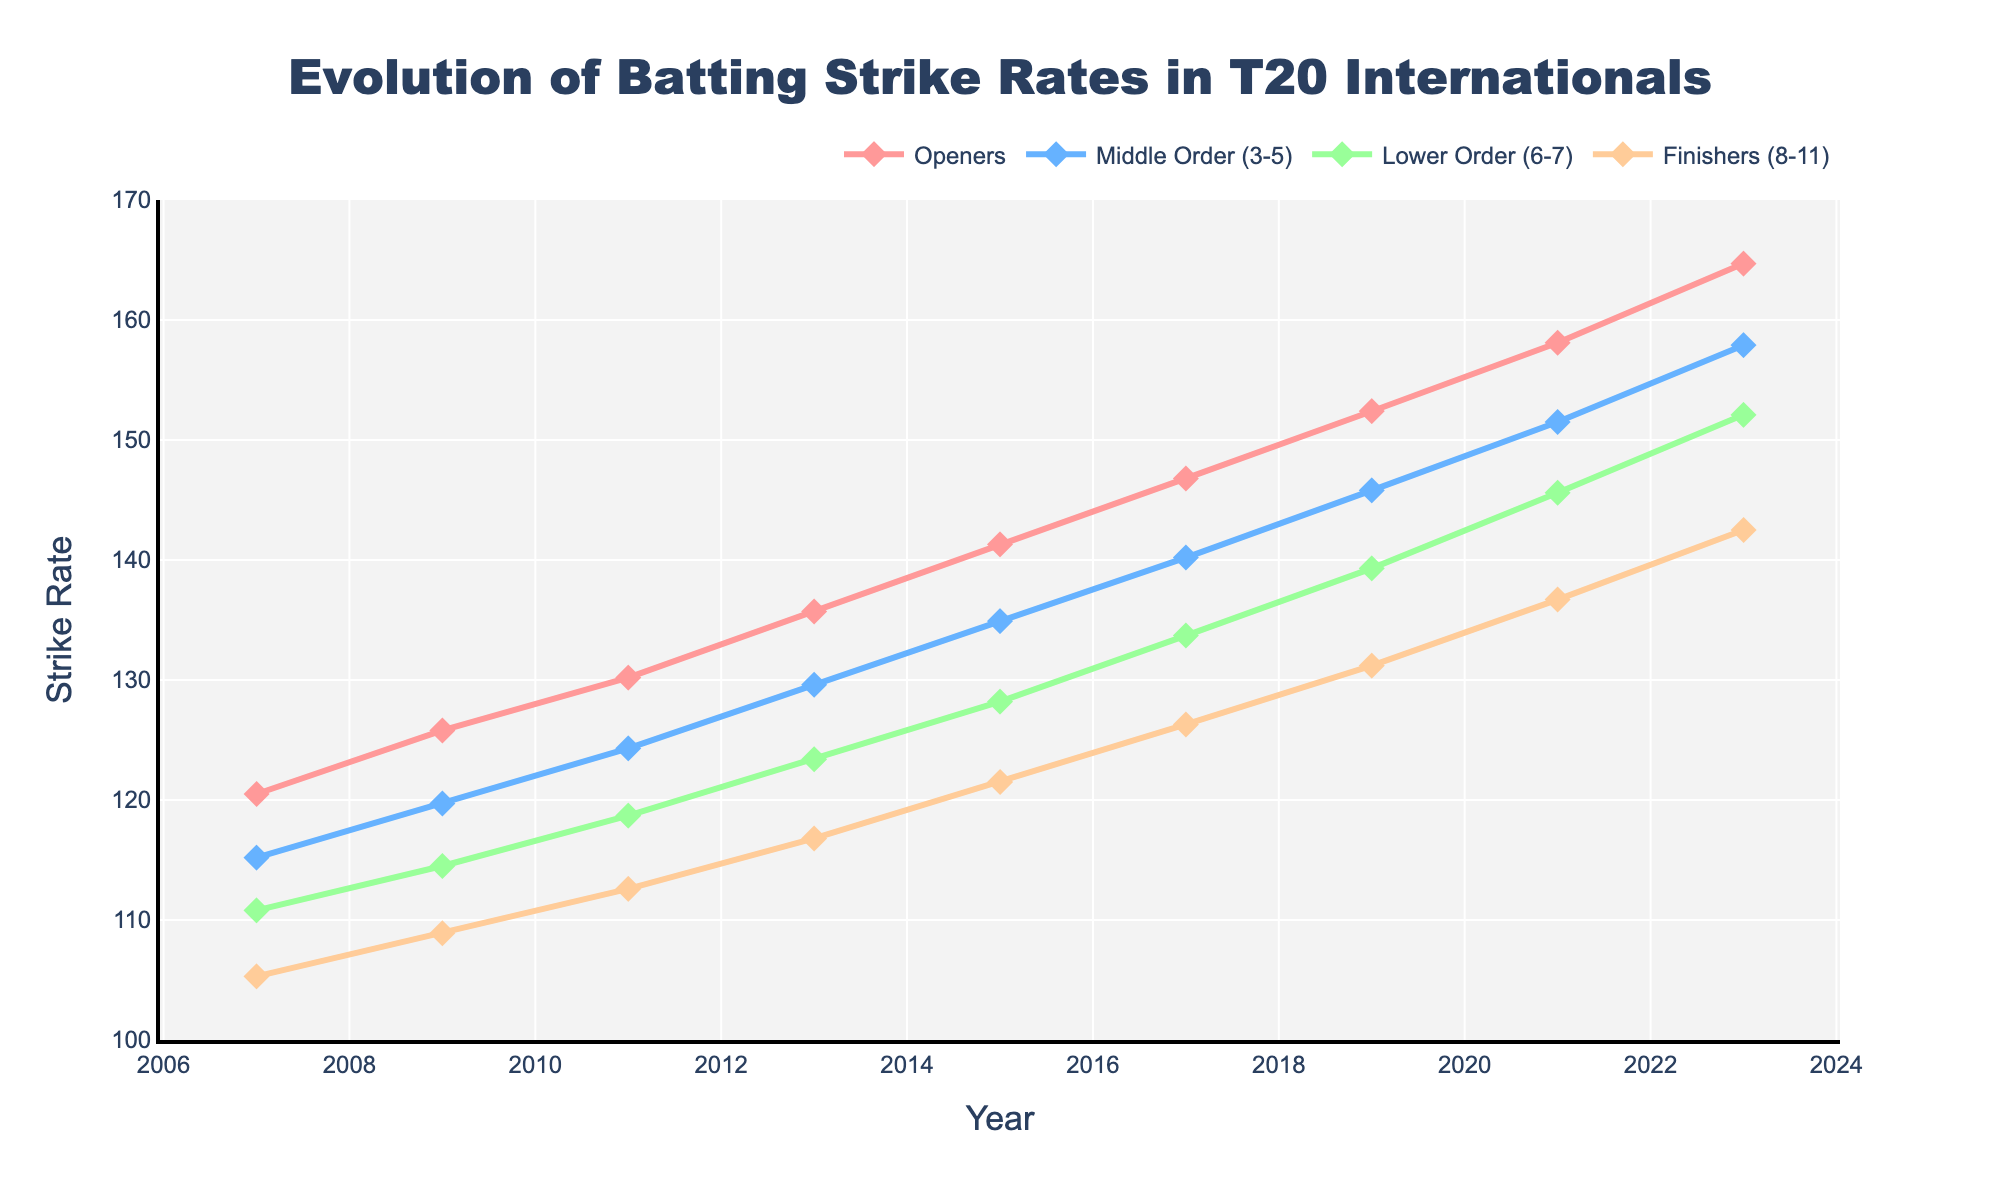What was the strike rate improvement for Openers from 2007 to 2023? The strike rate for Openers in 2007 was 120.5 and in 2023 it was 164.7. The improvement is calculated by subtracting the 2007 value from the 2023 value, which is 164.7 - 120.5 = 44.2
Answer: 44.2 Which playing position had the smallest increase in strike rate from 2007 to 2023? We need to calculate the strike rate improvement for each position from 2007 to 2023: Openers (164.7 - 120.5 = 44.2), Middle Order (157.9 - 115.2 = 42.7), Lower Order (152.1 - 110.8 = 41.3), Finishers (142.5 - 105.3 = 37.2). The smallest increase is for Finishers.
Answer: Finishers Can you rank the playing positions by strike rate in 2023? Inspecting the strike rates for 2023: Openers (164.7), Middle Order (157.9), Lower Order (152.1), Finishers (142.5). Ranking from highest to lowest is: Openers, Middle Order, Lower Order, Finishers.
Answer: Openers, Middle Order, Lower Order, Finishers How does the strike rate of Middle Order in 2017 compare to Openers in 2009? The strike rate of Middle Order in 2017 is 140.2, and for Openers in 2009 it is 125.8. Middle Order in 2017 has a higher strike rate compared to Openers in 2009.
Answer: Middle Order in 2017 > Openers in 2009 Which year showed the highest strike rate for Finishers, and what was the value? By inspecting the values for Finishers over the years: 2007 (105.3), 2009 (108.9), 2011 (112.6), 2013 (116.8), 2015 (121.5), 2017 (126.3), 2019 (131.2), 2021 (136.7), and 2023 (142.5), the highest is in 2023 with a value of 142.5.
Answer: 2023, 142.5 What is the average strike rate for Lower Order across all the years listed? To find the average, sum all the values for Lower Order and divide by the number of years: (110.8 + 114.5 + 118.7 + 123.4 + 128.2 + 133.7 + 139.3 + 145.6 + 152.1). The sum is 1066.3 and there are 9 years, so the average is 1066.3 / 9 = 118.5
Answer: 118.5 By how much did the strike rate for Middle Order change from 2013 to 2019? The strike rate for Middle Order in 2013 was 129.6 and in 2019 it was 145.8. The change is calculated by 145.8 - 129.6 = 16.2
Answer: 16.2 